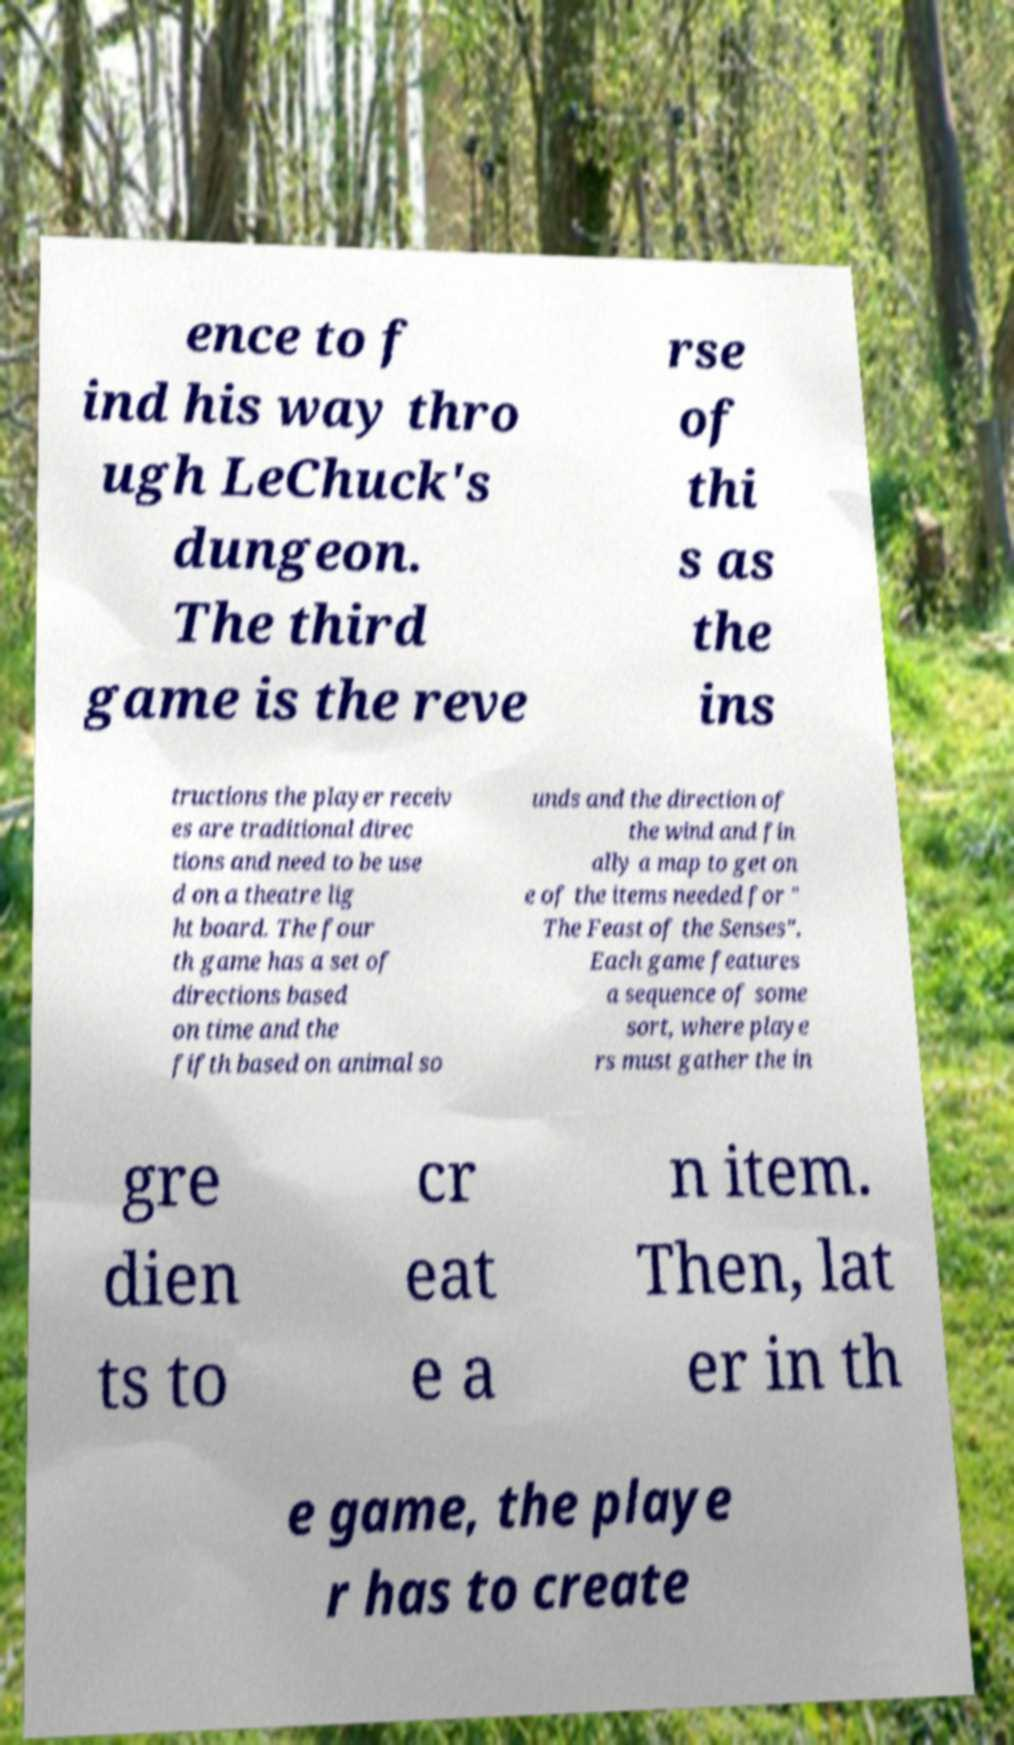I need the written content from this picture converted into text. Can you do that? ence to f ind his way thro ugh LeChuck's dungeon. The third game is the reve rse of thi s as the ins tructions the player receiv es are traditional direc tions and need to be use d on a theatre lig ht board. The four th game has a set of directions based on time and the fifth based on animal so unds and the direction of the wind and fin ally a map to get on e of the items needed for " The Feast of the Senses". Each game features a sequence of some sort, where playe rs must gather the in gre dien ts to cr eat e a n item. Then, lat er in th e game, the playe r has to create 